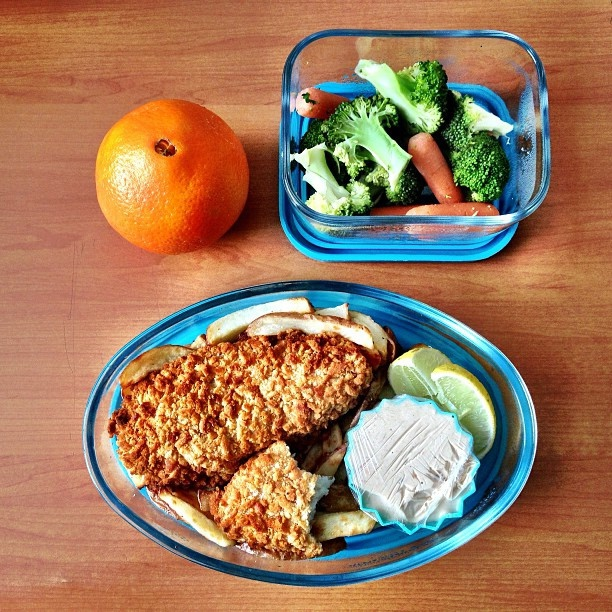Describe the objects in this image and their specific colors. I can see bowl in maroon, ivory, tan, black, and khaki tones, bowl in maroon, black, salmon, beige, and teal tones, broccoli in maroon, black, lightyellow, darkgreen, and lightgreen tones, orange in maroon, orange, brown, and red tones, and carrot in maroon, salmon, darkgray, and lightpink tones in this image. 